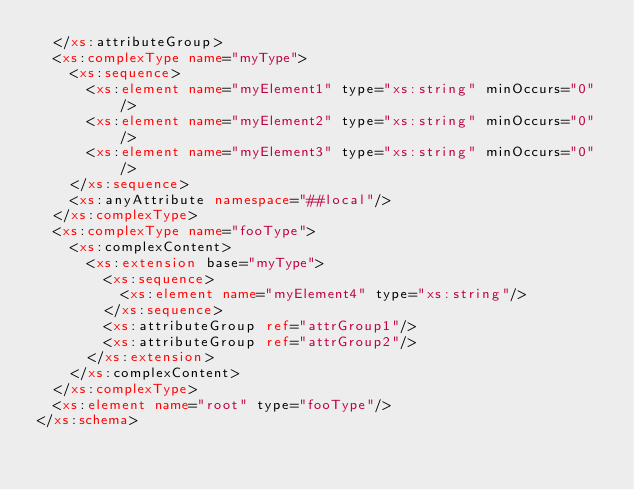Convert code to text. <code><loc_0><loc_0><loc_500><loc_500><_XML_>	</xs:attributeGroup>
	<xs:complexType name="myType">
		<xs:sequence>
			<xs:element name="myElement1" type="xs:string" minOccurs="0"/>
			<xs:element name="myElement2" type="xs:string" minOccurs="0"/>
			<xs:element name="myElement3" type="xs:string" minOccurs="0"/>
		</xs:sequence>
		<xs:anyAttribute namespace="##local"/>
	</xs:complexType>
	<xs:complexType name="fooType">
		<xs:complexContent>
			<xs:extension base="myType">
				<xs:sequence>
					<xs:element name="myElement4" type="xs:string"/>
				</xs:sequence>
				<xs:attributeGroup ref="attrGroup1"/>
				<xs:attributeGroup ref="attrGroup2"/>
			</xs:extension>
		</xs:complexContent>
	</xs:complexType>
	<xs:element name="root" type="fooType"/>
</xs:schema>
</code> 